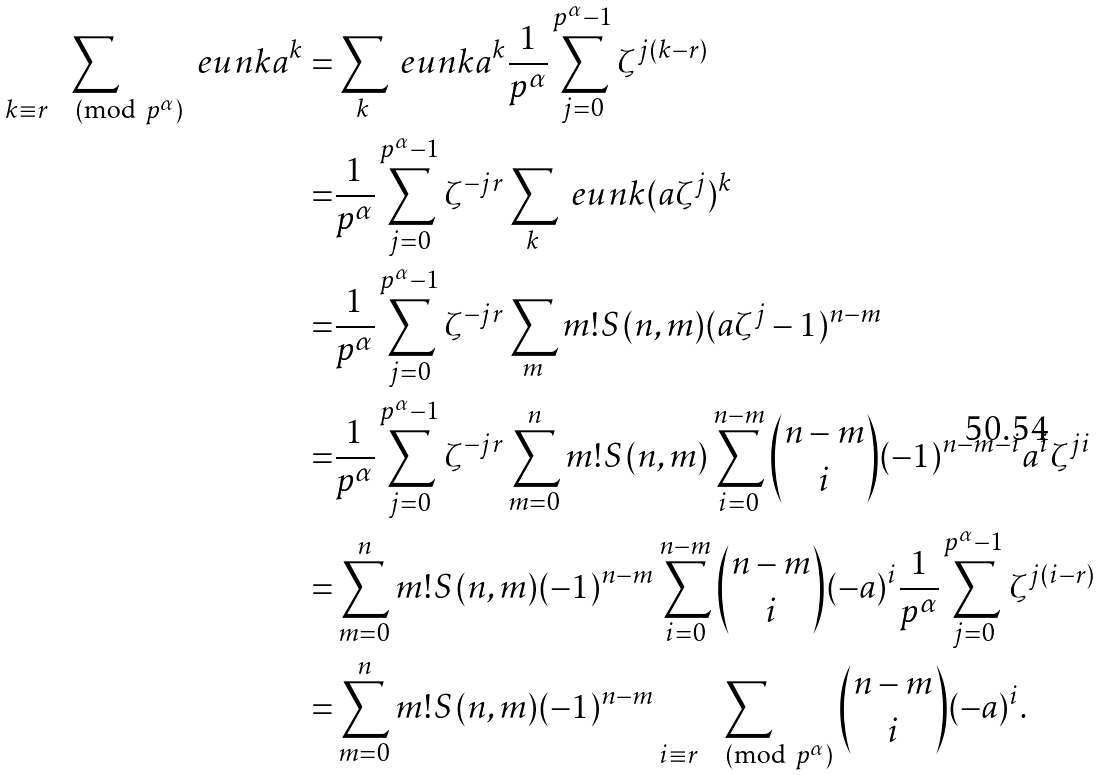Convert formula to latex. <formula><loc_0><loc_0><loc_500><loc_500>\sum _ { k \equiv r \pmod { p ^ { \alpha } } } \ e u n k a ^ { k } = & \sum _ { k } \ e u n k a ^ { k } \frac { 1 } { p ^ { \alpha } } \sum _ { j = 0 } ^ { p ^ { \alpha } - 1 } \zeta ^ { j ( k - r ) } \\ = & \frac { 1 } { p ^ { \alpha } } \sum _ { j = 0 } ^ { p ^ { \alpha } - 1 } \zeta ^ { - j r } \sum _ { k } \ e u n k ( a \zeta ^ { j } ) ^ { k } \\ = & \frac { 1 } { p ^ { \alpha } } \sum _ { j = 0 } ^ { p ^ { \alpha } - 1 } \zeta ^ { - j r } \sum _ { m } m ! S ( n , m ) ( a \zeta ^ { j } - 1 ) ^ { n - m } \\ = & \frac { 1 } { p ^ { \alpha } } \sum _ { j = 0 } ^ { p ^ { \alpha } - 1 } \zeta ^ { - j r } \sum _ { m = 0 } ^ { n } m ! S ( n , m ) \sum _ { i = 0 } ^ { n - m } \binom { n - m } { i } ( - 1 ) ^ { n - m - i } a ^ { i } \zeta ^ { j i } \\ = & \sum _ { m = 0 } ^ { n } m ! S ( n , m ) ( - 1 ) ^ { n - m } \sum _ { i = 0 } ^ { n - m } \binom { n - m } { i } ( - a ) ^ { i } \frac { 1 } { p ^ { \alpha } } \sum _ { j = 0 } ^ { p ^ { \alpha } - 1 } \zeta ^ { j ( i - r ) } \\ = & \sum _ { m = 0 } ^ { n } m ! S ( n , m ) ( - 1 ) ^ { n - m } \sum _ { i \equiv r \pmod { p ^ { \alpha } } } \binom { n - m } { i } ( - a ) ^ { i } .</formula> 